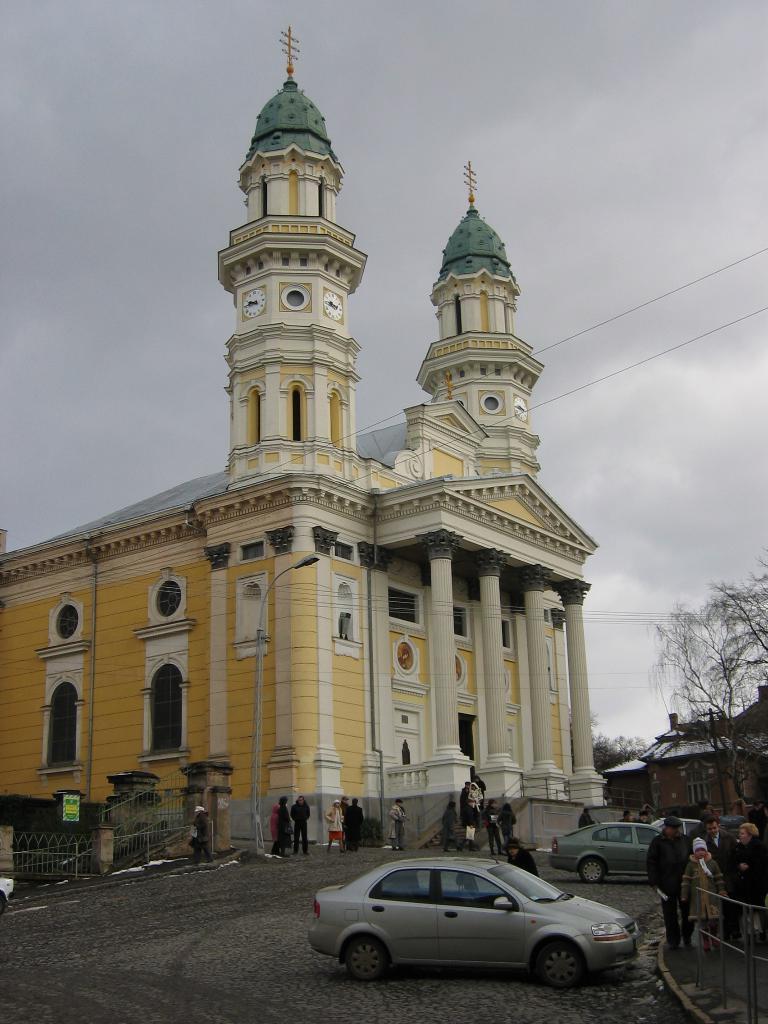In one or two sentences, can you explain what this image depicts? In this image I can see the vehicles. To the side of the vehicle I can see people and the railing. These people are wearing the different color dresses. In the background I can see the building, trees and the sky. 